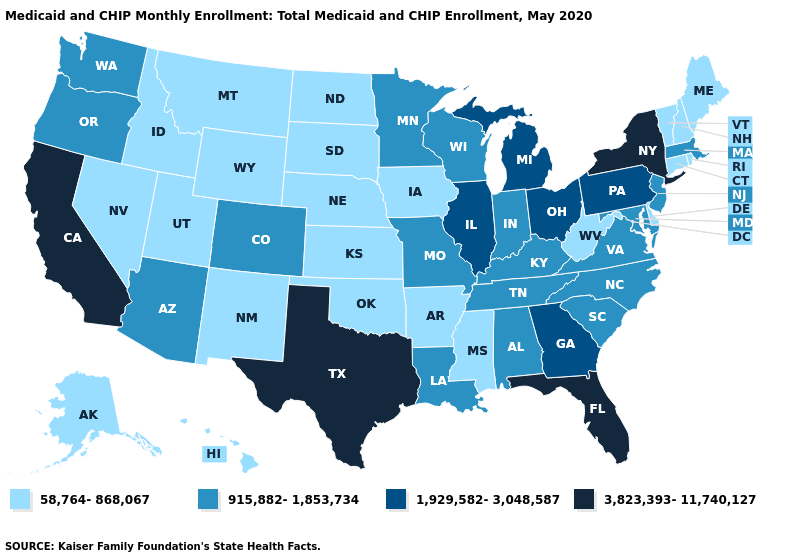Name the states that have a value in the range 3,823,393-11,740,127?
Be succinct. California, Florida, New York, Texas. Does Colorado have the highest value in the West?
Concise answer only. No. What is the highest value in states that border North Carolina?
Concise answer only. 1,929,582-3,048,587. What is the value of Alabama?
Answer briefly. 915,882-1,853,734. What is the lowest value in the USA?
Answer briefly. 58,764-868,067. How many symbols are there in the legend?
Concise answer only. 4. Does Oregon have the lowest value in the USA?
Keep it brief. No. Is the legend a continuous bar?
Keep it brief. No. What is the value of Montana?
Answer briefly. 58,764-868,067. Name the states that have a value in the range 915,882-1,853,734?
Short answer required. Alabama, Arizona, Colorado, Indiana, Kentucky, Louisiana, Maryland, Massachusetts, Minnesota, Missouri, New Jersey, North Carolina, Oregon, South Carolina, Tennessee, Virginia, Washington, Wisconsin. What is the value of Missouri?
Short answer required. 915,882-1,853,734. Among the states that border Kentucky , does Indiana have the lowest value?
Answer briefly. No. Does California have the lowest value in the West?
Be succinct. No. Does Vermont have a lower value than Hawaii?
Give a very brief answer. No. Name the states that have a value in the range 58,764-868,067?
Give a very brief answer. Alaska, Arkansas, Connecticut, Delaware, Hawaii, Idaho, Iowa, Kansas, Maine, Mississippi, Montana, Nebraska, Nevada, New Hampshire, New Mexico, North Dakota, Oklahoma, Rhode Island, South Dakota, Utah, Vermont, West Virginia, Wyoming. 